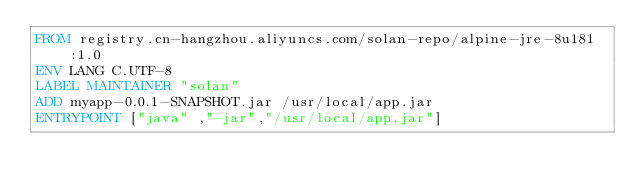Convert code to text. <code><loc_0><loc_0><loc_500><loc_500><_Dockerfile_>FROM registry.cn-hangzhou.aliyuncs.com/solan-repo/alpine-jre-8u181:1.0
ENV LANG C.UTF-8
LABEL MAINTAINER "solan"
ADD myapp-0.0.1-SNAPSHOT.jar /usr/local/app.jar
ENTRYPOINT ["java" ,"-jar","/usr/local/app.jar"]
</code> 